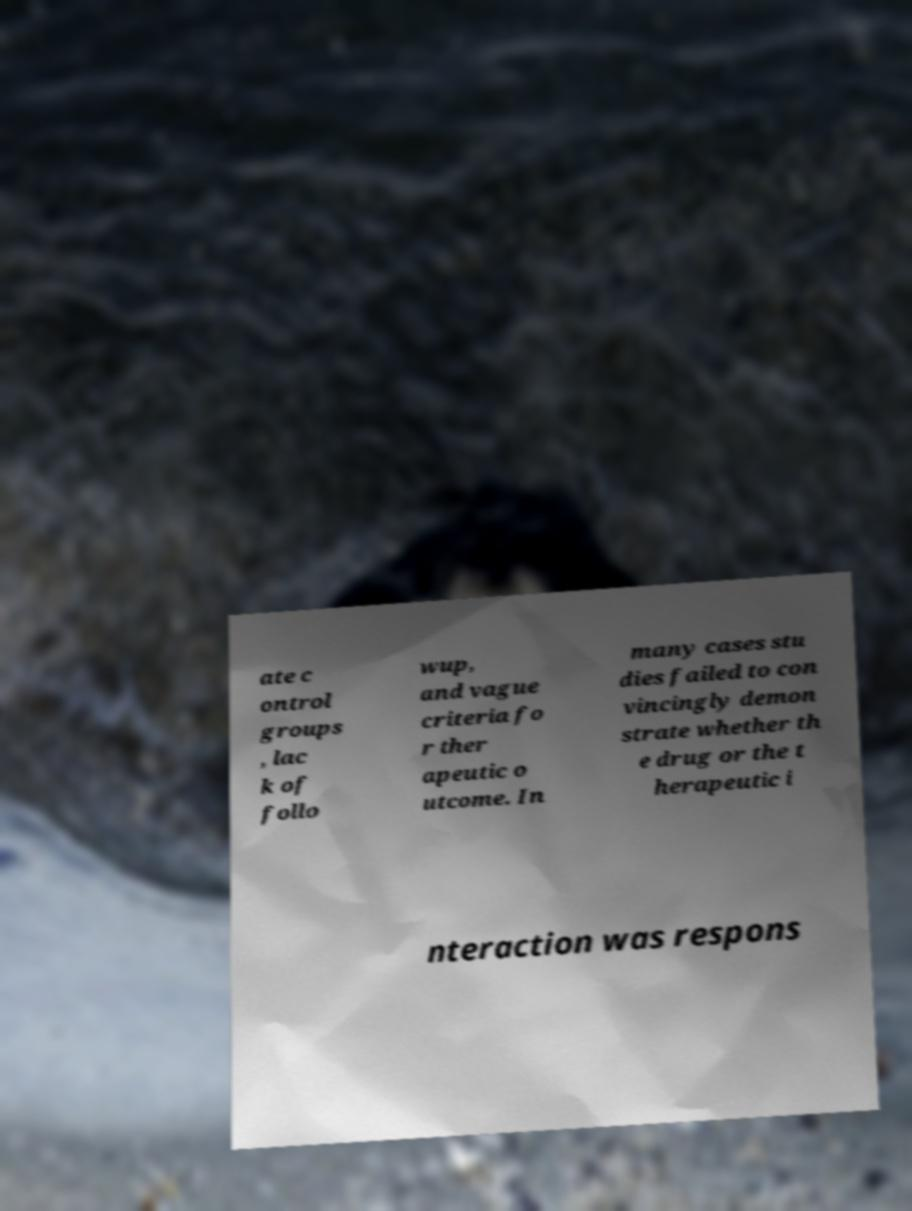Please identify and transcribe the text found in this image. ate c ontrol groups , lac k of follo wup, and vague criteria fo r ther apeutic o utcome. In many cases stu dies failed to con vincingly demon strate whether th e drug or the t herapeutic i nteraction was respons 